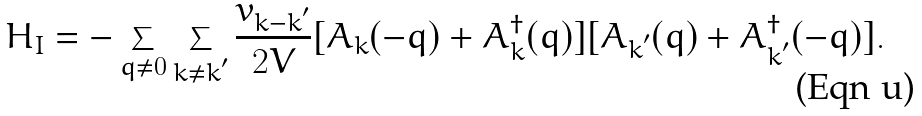Convert formula to latex. <formula><loc_0><loc_0><loc_500><loc_500>H _ { I } = - \sum _ { { q } \neq 0 } \sum _ { { k } \neq { k } ^ { ^ { \prime } } } \frac { v _ { { k } - { k } ^ { ^ { \prime } } } } { 2 V } [ A _ { k } ( - { q } ) + A ^ { \dagger } _ { k } ( { q } ) ] [ A _ { { k } ^ { ^ { \prime } } } ( { q } ) + A ^ { \dagger } _ { { k } ^ { ^ { \prime } } } ( - { q } ) ] .</formula> 